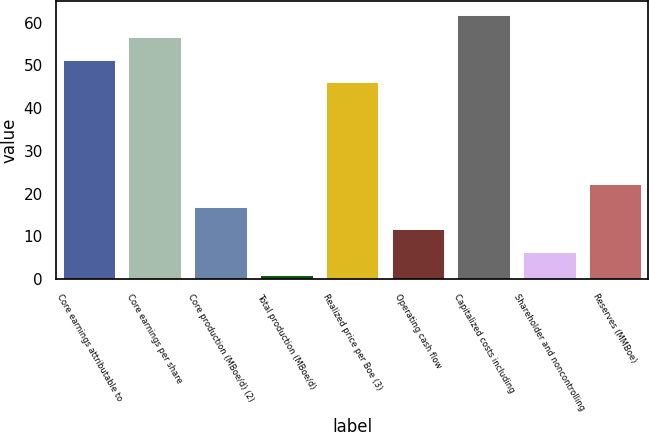Convert chart to OTSL. <chart><loc_0><loc_0><loc_500><loc_500><bar_chart><fcel>Core earnings attributable to<fcel>Core earnings per share<fcel>Core production (MBoe/d) (2)<fcel>Total production (MBoe/d)<fcel>Realized price per Boe (3)<fcel>Operating cash flow<fcel>Capitalized costs including<fcel>Shareholder and noncontrolling<fcel>Reserves (MMBoe)<nl><fcel>51.3<fcel>56.6<fcel>16.9<fcel>1<fcel>46<fcel>11.6<fcel>61.9<fcel>6.3<fcel>22.2<nl></chart> 